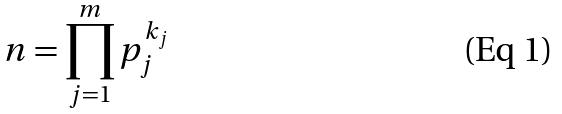Convert formula to latex. <formula><loc_0><loc_0><loc_500><loc_500>n = \prod _ { j = 1 } ^ { m } p _ { j } ^ { k _ { j } }</formula> 